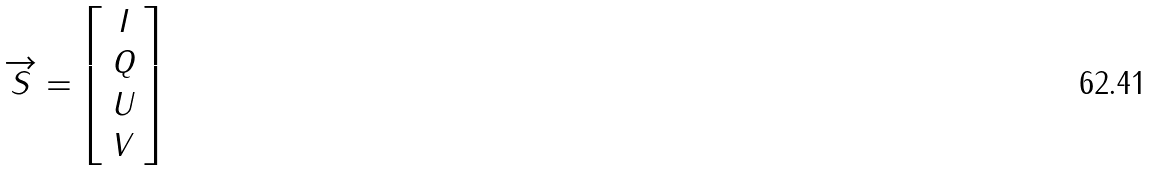<formula> <loc_0><loc_0><loc_500><loc_500>\overrightarrow { S } = \left [ \begin{array} { c } I \\ Q \\ U \\ V \end{array} \right ]</formula> 